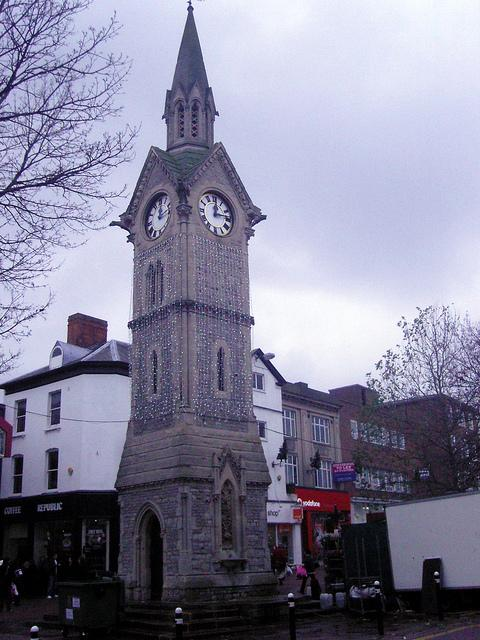What is near the apex of the tower? clock 